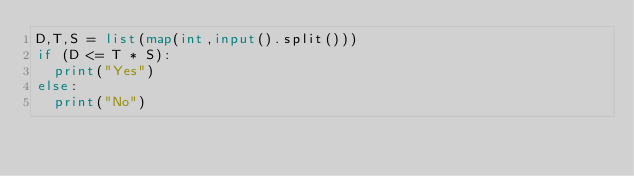<code> <loc_0><loc_0><loc_500><loc_500><_Python_>D,T,S = list(map(int,input().split())) 
if (D <= T * S):
  print("Yes")
else:
  print("No")
</code> 